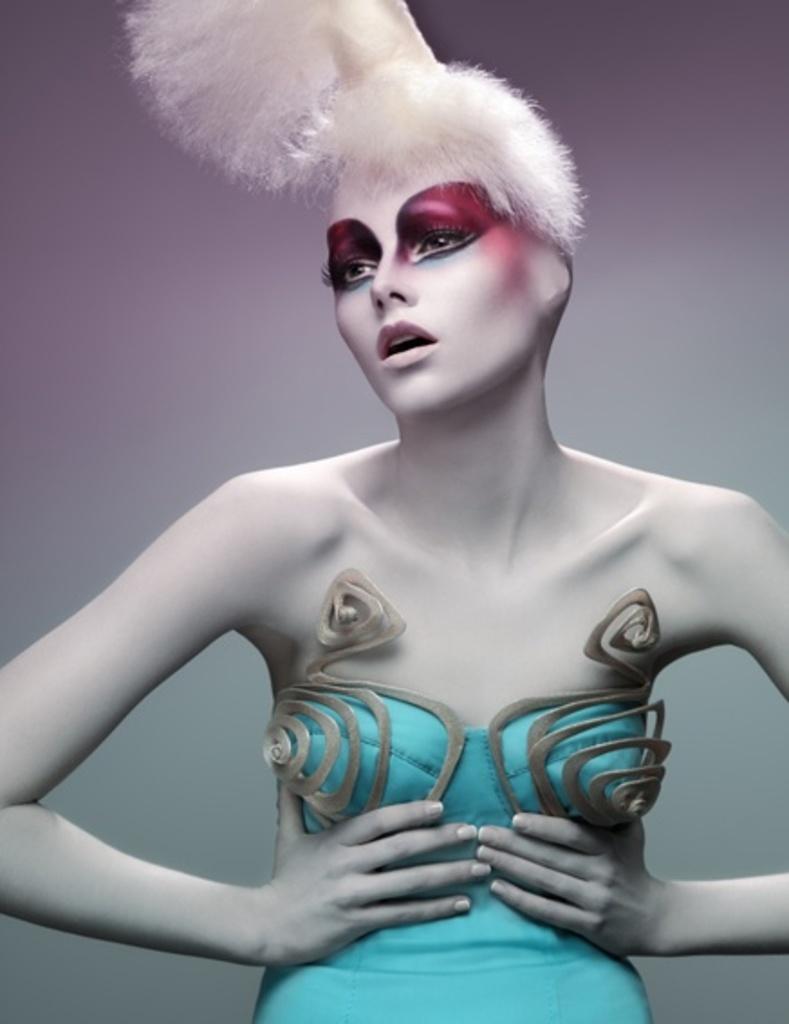Can you describe this image briefly? There is a lady with a blue dress. 